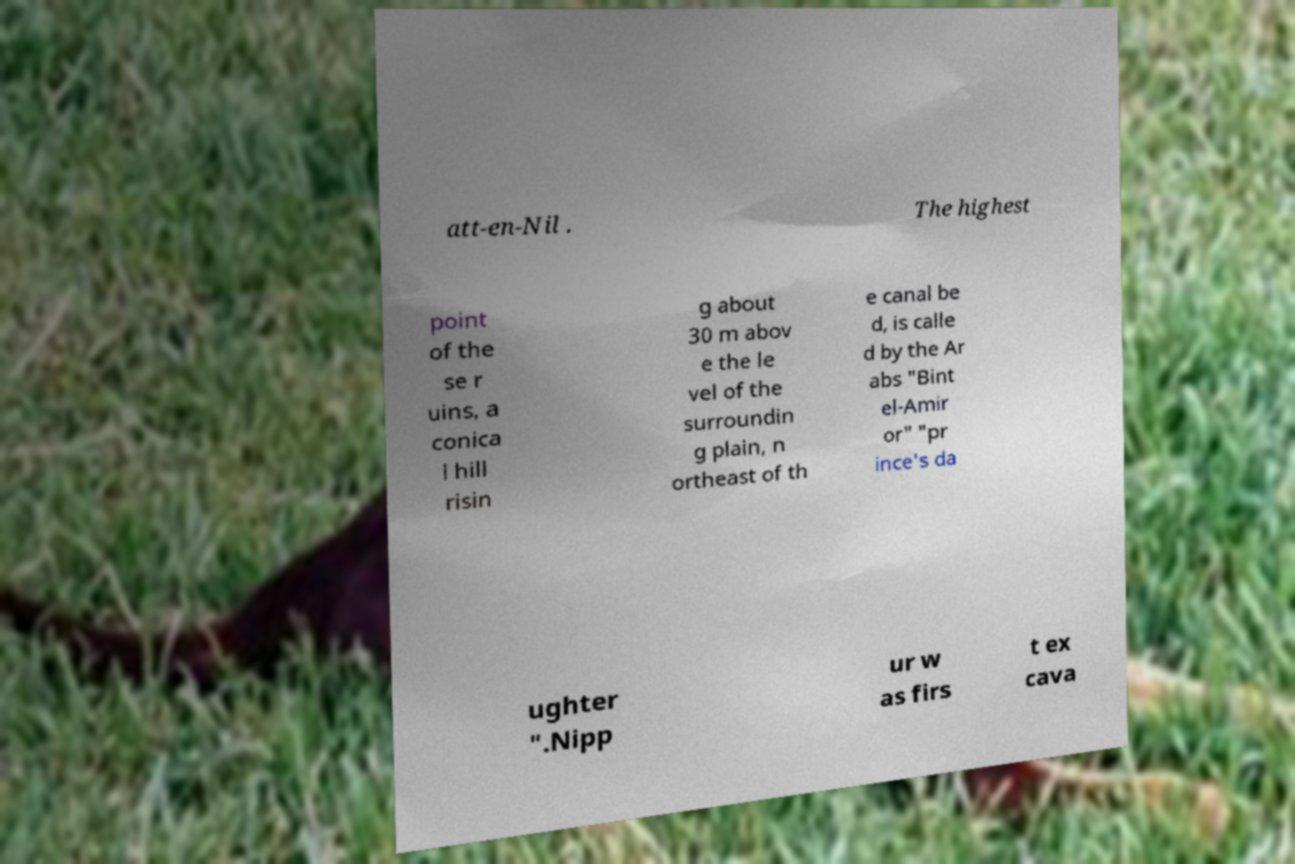Could you extract and type out the text from this image? att-en-Nil . The highest point of the se r uins, a conica l hill risin g about 30 m abov e the le vel of the surroundin g plain, n ortheast of th e canal be d, is calle d by the Ar abs "Bint el-Amir or" "pr ince's da ughter ".Nipp ur w as firs t ex cava 